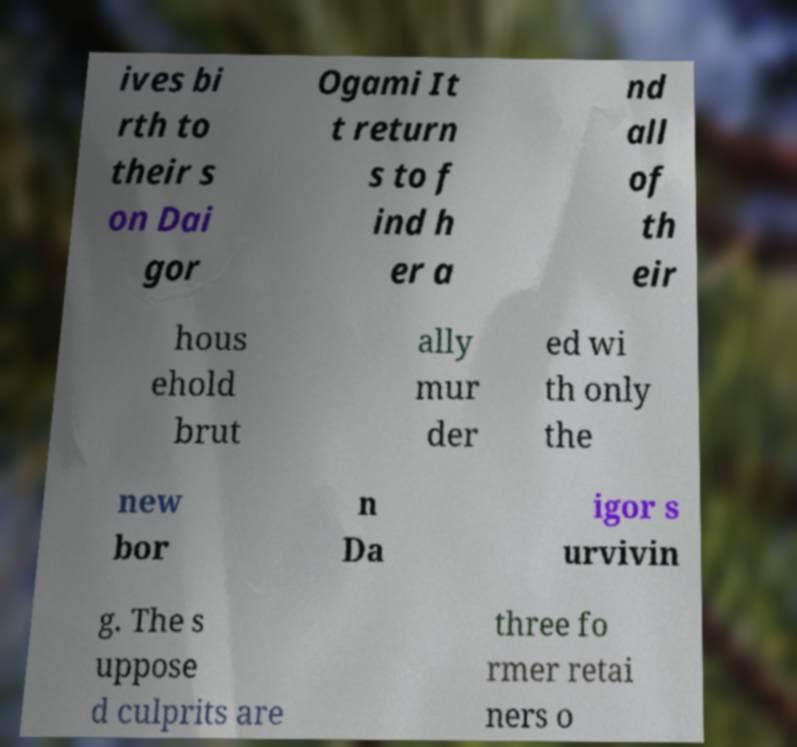Can you read and provide the text displayed in the image?This photo seems to have some interesting text. Can you extract and type it out for me? ives bi rth to their s on Dai gor Ogami It t return s to f ind h er a nd all of th eir hous ehold brut ally mur der ed wi th only the new bor n Da igor s urvivin g. The s uppose d culprits are three fo rmer retai ners o 